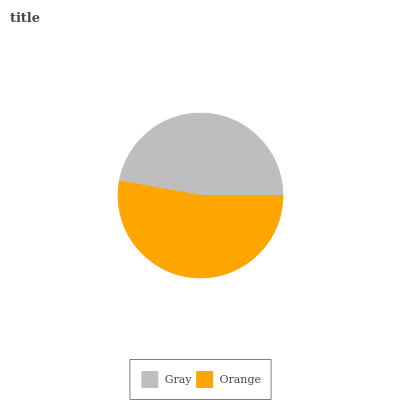Is Gray the minimum?
Answer yes or no. Yes. Is Orange the maximum?
Answer yes or no. Yes. Is Orange the minimum?
Answer yes or no. No. Is Orange greater than Gray?
Answer yes or no. Yes. Is Gray less than Orange?
Answer yes or no. Yes. Is Gray greater than Orange?
Answer yes or no. No. Is Orange less than Gray?
Answer yes or no. No. Is Orange the high median?
Answer yes or no. Yes. Is Gray the low median?
Answer yes or no. Yes. Is Gray the high median?
Answer yes or no. No. Is Orange the low median?
Answer yes or no. No. 